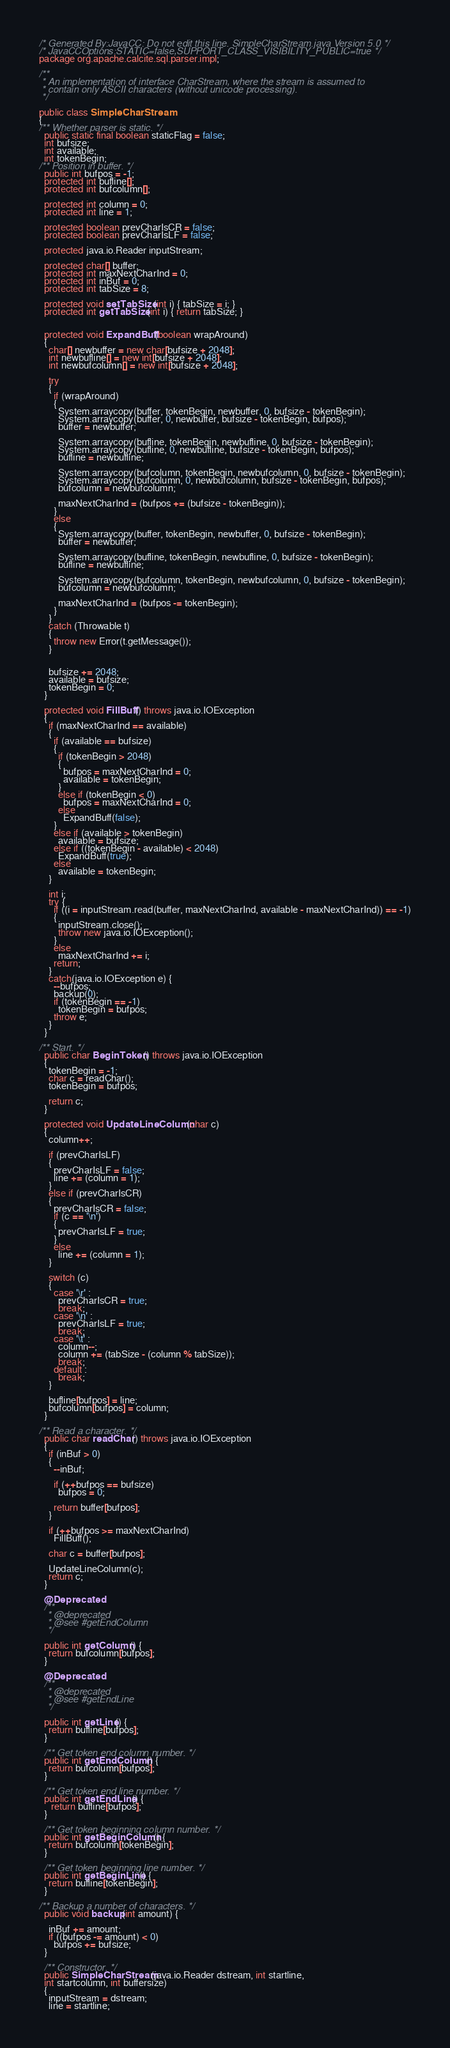Convert code to text. <code><loc_0><loc_0><loc_500><loc_500><_Java_>/* Generated By:JavaCC: Do not edit this line. SimpleCharStream.java Version 5.0 */
/* JavaCCOptions:STATIC=false,SUPPORT_CLASS_VISIBILITY_PUBLIC=true */
package org.apache.calcite.sql.parser.impl;

/**
 * An implementation of interface CharStream, where the stream is assumed to
 * contain only ASCII characters (without unicode processing).
 */

public class SimpleCharStream
{
/** Whether parser is static. */
  public static final boolean staticFlag = false;
  int bufsize;
  int available;
  int tokenBegin;
/** Position in buffer. */
  public int bufpos = -1;
  protected int bufline[];
  protected int bufcolumn[];

  protected int column = 0;
  protected int line = 1;

  protected boolean prevCharIsCR = false;
  protected boolean prevCharIsLF = false;

  protected java.io.Reader inputStream;

  protected char[] buffer;
  protected int maxNextCharInd = 0;
  protected int inBuf = 0;
  protected int tabSize = 8;

  protected void setTabSize(int i) { tabSize = i; }
  protected int getTabSize(int i) { return tabSize; }


  protected void ExpandBuff(boolean wrapAround)
  {
    char[] newbuffer = new char[bufsize + 2048];
    int newbufline[] = new int[bufsize + 2048];
    int newbufcolumn[] = new int[bufsize + 2048];

    try
    {
      if (wrapAround)
      {
        System.arraycopy(buffer, tokenBegin, newbuffer, 0, bufsize - tokenBegin);
        System.arraycopy(buffer, 0, newbuffer, bufsize - tokenBegin, bufpos);
        buffer = newbuffer;

        System.arraycopy(bufline, tokenBegin, newbufline, 0, bufsize - tokenBegin);
        System.arraycopy(bufline, 0, newbufline, bufsize - tokenBegin, bufpos);
        bufline = newbufline;

        System.arraycopy(bufcolumn, tokenBegin, newbufcolumn, 0, bufsize - tokenBegin);
        System.arraycopy(bufcolumn, 0, newbufcolumn, bufsize - tokenBegin, bufpos);
        bufcolumn = newbufcolumn;

        maxNextCharInd = (bufpos += (bufsize - tokenBegin));
      }
      else
      {
        System.arraycopy(buffer, tokenBegin, newbuffer, 0, bufsize - tokenBegin);
        buffer = newbuffer;

        System.arraycopy(bufline, tokenBegin, newbufline, 0, bufsize - tokenBegin);
        bufline = newbufline;

        System.arraycopy(bufcolumn, tokenBegin, newbufcolumn, 0, bufsize - tokenBegin);
        bufcolumn = newbufcolumn;

        maxNextCharInd = (bufpos -= tokenBegin);
      }
    }
    catch (Throwable t)
    {
      throw new Error(t.getMessage());
    }


    bufsize += 2048;
    available = bufsize;
    tokenBegin = 0;
  }

  protected void FillBuff() throws java.io.IOException
  {
    if (maxNextCharInd == available)
    {
      if (available == bufsize)
      {
        if (tokenBegin > 2048)
        {
          bufpos = maxNextCharInd = 0;
          available = tokenBegin;
        }
        else if (tokenBegin < 0)
          bufpos = maxNextCharInd = 0;
        else
          ExpandBuff(false);
      }
      else if (available > tokenBegin)
        available = bufsize;
      else if ((tokenBegin - available) < 2048)
        ExpandBuff(true);
      else
        available = tokenBegin;
    }

    int i;
    try {
      if ((i = inputStream.read(buffer, maxNextCharInd, available - maxNextCharInd)) == -1)
      {
        inputStream.close();
        throw new java.io.IOException();
      }
      else
        maxNextCharInd += i;
      return;
    }
    catch(java.io.IOException e) {
      --bufpos;
      backup(0);
      if (tokenBegin == -1)
        tokenBegin = bufpos;
      throw e;
    }
  }

/** Start. */
  public char BeginToken() throws java.io.IOException
  {
    tokenBegin = -1;
    char c = readChar();
    tokenBegin = bufpos;

    return c;
  }

  protected void UpdateLineColumn(char c)
  {
    column++;

    if (prevCharIsLF)
    {
      prevCharIsLF = false;
      line += (column = 1);
    }
    else if (prevCharIsCR)
    {
      prevCharIsCR = false;
      if (c == '\n')
      {
        prevCharIsLF = true;
      }
      else
        line += (column = 1);
    }

    switch (c)
    {
      case '\r' :
        prevCharIsCR = true;
        break;
      case '\n' :
        prevCharIsLF = true;
        break;
      case '\t' :
        column--;
        column += (tabSize - (column % tabSize));
        break;
      default :
        break;
    }

    bufline[bufpos] = line;
    bufcolumn[bufpos] = column;
  }

/** Read a character. */
  public char readChar() throws java.io.IOException
  {
    if (inBuf > 0)
    {
      --inBuf;

      if (++bufpos == bufsize)
        bufpos = 0;

      return buffer[bufpos];
    }

    if (++bufpos >= maxNextCharInd)
      FillBuff();

    char c = buffer[bufpos];

    UpdateLineColumn(c);
    return c;
  }

  @Deprecated
  /**
   * @deprecated
   * @see #getEndColumn
   */

  public int getColumn() {
    return bufcolumn[bufpos];
  }

  @Deprecated
  /**
   * @deprecated
   * @see #getEndLine
   */

  public int getLine() {
    return bufline[bufpos];
  }

  /** Get token end column number. */
  public int getEndColumn() {
    return bufcolumn[bufpos];
  }

  /** Get token end line number. */
  public int getEndLine() {
     return bufline[bufpos];
  }

  /** Get token beginning column number. */
  public int getBeginColumn() {
    return bufcolumn[tokenBegin];
  }

  /** Get token beginning line number. */
  public int getBeginLine() {
    return bufline[tokenBegin];
  }

/** Backup a number of characters. */
  public void backup(int amount) {

    inBuf += amount;
    if ((bufpos -= amount) < 0)
      bufpos += bufsize;
  }

  /** Constructor. */
  public SimpleCharStream(java.io.Reader dstream, int startline,
  int startcolumn, int buffersize)
  {
    inputStream = dstream;
    line = startline;</code> 